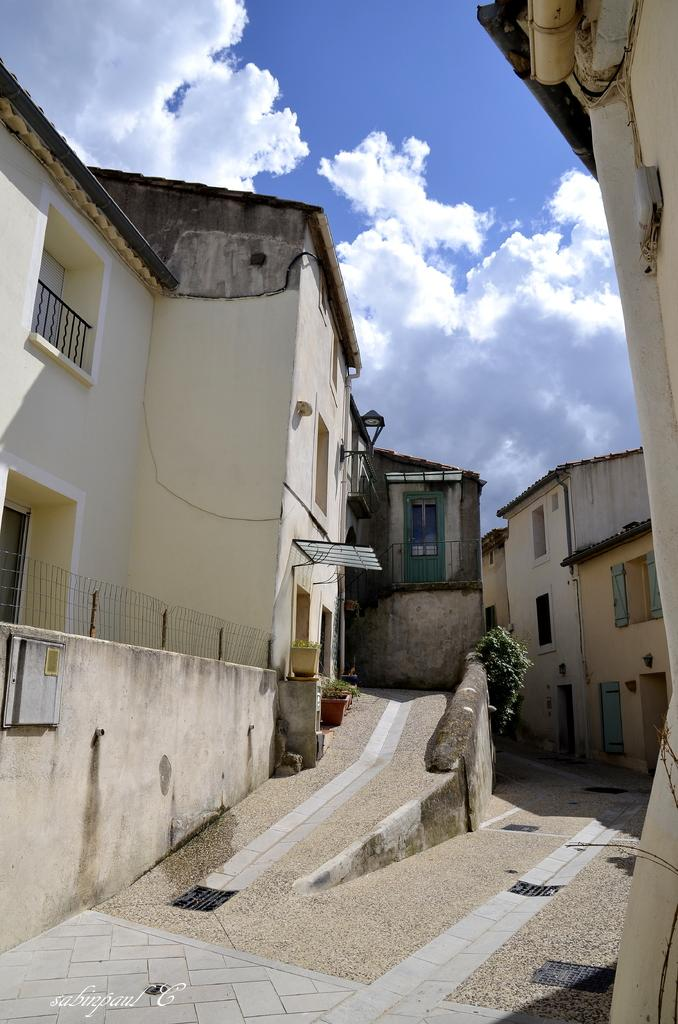What type of structures can be seen in the image? There are buildings in the image. What other elements can be found in the image besides buildings? There are plants, a road, windows, a fence, a wall, and text at the bottom of the image. What is visible in the background of the image? Sky is visible in the image, with clouds present. What type of pie is being served on the fence in the image? There is no pie present in the image; it features buildings, plants, a road, windows, a fence, a wall, text, and sky with clouds. What is the level of friction between the wall and the clouds in the image? There is no friction between the wall and the clouds in the image, as they are not in contact with each other. 